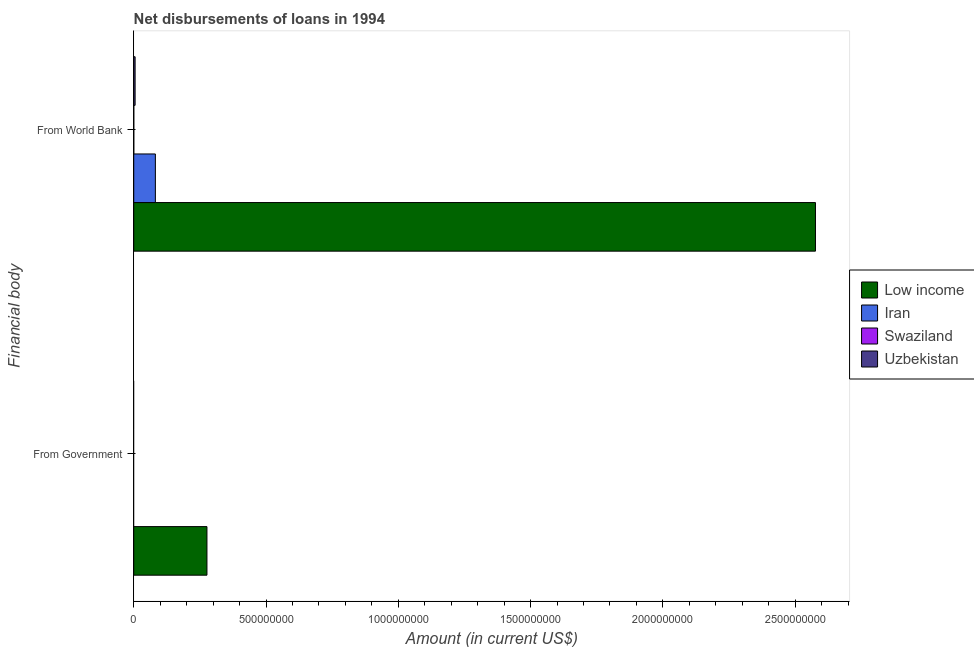How many different coloured bars are there?
Give a very brief answer. 4. What is the label of the 2nd group of bars from the top?
Provide a succinct answer. From Government. What is the net disbursements of loan from world bank in Uzbekistan?
Provide a short and direct response. 5.18e+06. Across all countries, what is the maximum net disbursements of loan from world bank?
Your answer should be very brief. 2.58e+09. Across all countries, what is the minimum net disbursements of loan from government?
Offer a terse response. 0. What is the total net disbursements of loan from government in the graph?
Give a very brief answer. 2.77e+08. What is the difference between the net disbursements of loan from world bank in Low income and that in Uzbekistan?
Make the answer very short. 2.57e+09. What is the difference between the net disbursements of loan from world bank in Low income and the net disbursements of loan from government in Uzbekistan?
Ensure brevity in your answer.  2.58e+09. What is the average net disbursements of loan from government per country?
Your answer should be very brief. 6.92e+07. What is the difference between the net disbursements of loan from government and net disbursements of loan from world bank in Low income?
Your answer should be compact. -2.30e+09. What is the ratio of the net disbursements of loan from world bank in Low income to that in Uzbekistan?
Ensure brevity in your answer.  497.16. Is the net disbursements of loan from world bank in Uzbekistan less than that in Iran?
Ensure brevity in your answer.  Yes. In how many countries, is the net disbursements of loan from world bank greater than the average net disbursements of loan from world bank taken over all countries?
Your response must be concise. 1. How many bars are there?
Ensure brevity in your answer.  5. Are all the bars in the graph horizontal?
Offer a very short reply. Yes. What is the difference between two consecutive major ticks on the X-axis?
Your answer should be very brief. 5.00e+08. Does the graph contain any zero values?
Give a very brief answer. Yes. Does the graph contain grids?
Keep it short and to the point. No. Where does the legend appear in the graph?
Keep it short and to the point. Center right. How many legend labels are there?
Ensure brevity in your answer.  4. What is the title of the graph?
Make the answer very short. Net disbursements of loans in 1994. Does "St. Martin (French part)" appear as one of the legend labels in the graph?
Provide a short and direct response. No. What is the label or title of the Y-axis?
Offer a very short reply. Financial body. What is the Amount (in current US$) in Low income in From Government?
Make the answer very short. 2.77e+08. What is the Amount (in current US$) of Swaziland in From Government?
Offer a very short reply. 0. What is the Amount (in current US$) of Uzbekistan in From Government?
Offer a terse response. 0. What is the Amount (in current US$) of Low income in From World Bank?
Give a very brief answer. 2.58e+09. What is the Amount (in current US$) of Iran in From World Bank?
Your response must be concise. 8.18e+07. What is the Amount (in current US$) in Swaziland in From World Bank?
Ensure brevity in your answer.  1.38e+05. What is the Amount (in current US$) of Uzbekistan in From World Bank?
Ensure brevity in your answer.  5.18e+06. Across all Financial body, what is the maximum Amount (in current US$) in Low income?
Your answer should be very brief. 2.58e+09. Across all Financial body, what is the maximum Amount (in current US$) of Iran?
Make the answer very short. 8.18e+07. Across all Financial body, what is the maximum Amount (in current US$) in Swaziland?
Ensure brevity in your answer.  1.38e+05. Across all Financial body, what is the maximum Amount (in current US$) of Uzbekistan?
Your response must be concise. 5.18e+06. Across all Financial body, what is the minimum Amount (in current US$) in Low income?
Provide a short and direct response. 2.77e+08. Across all Financial body, what is the minimum Amount (in current US$) in Iran?
Provide a short and direct response. 0. What is the total Amount (in current US$) in Low income in the graph?
Give a very brief answer. 2.85e+09. What is the total Amount (in current US$) of Iran in the graph?
Provide a succinct answer. 8.18e+07. What is the total Amount (in current US$) in Swaziland in the graph?
Your answer should be compact. 1.38e+05. What is the total Amount (in current US$) in Uzbekistan in the graph?
Ensure brevity in your answer.  5.18e+06. What is the difference between the Amount (in current US$) in Low income in From Government and that in From World Bank?
Offer a very short reply. -2.30e+09. What is the difference between the Amount (in current US$) in Low income in From Government and the Amount (in current US$) in Iran in From World Bank?
Keep it short and to the point. 1.95e+08. What is the difference between the Amount (in current US$) in Low income in From Government and the Amount (in current US$) in Swaziland in From World Bank?
Keep it short and to the point. 2.77e+08. What is the difference between the Amount (in current US$) in Low income in From Government and the Amount (in current US$) in Uzbekistan in From World Bank?
Keep it short and to the point. 2.72e+08. What is the average Amount (in current US$) in Low income per Financial body?
Give a very brief answer. 1.43e+09. What is the average Amount (in current US$) in Iran per Financial body?
Offer a very short reply. 4.09e+07. What is the average Amount (in current US$) in Swaziland per Financial body?
Your response must be concise. 6.90e+04. What is the average Amount (in current US$) in Uzbekistan per Financial body?
Provide a succinct answer. 2.59e+06. What is the difference between the Amount (in current US$) of Low income and Amount (in current US$) of Iran in From World Bank?
Provide a short and direct response. 2.49e+09. What is the difference between the Amount (in current US$) of Low income and Amount (in current US$) of Swaziland in From World Bank?
Ensure brevity in your answer.  2.58e+09. What is the difference between the Amount (in current US$) in Low income and Amount (in current US$) in Uzbekistan in From World Bank?
Your answer should be compact. 2.57e+09. What is the difference between the Amount (in current US$) in Iran and Amount (in current US$) in Swaziland in From World Bank?
Offer a terse response. 8.17e+07. What is the difference between the Amount (in current US$) of Iran and Amount (in current US$) of Uzbekistan in From World Bank?
Make the answer very short. 7.66e+07. What is the difference between the Amount (in current US$) of Swaziland and Amount (in current US$) of Uzbekistan in From World Bank?
Provide a succinct answer. -5.04e+06. What is the ratio of the Amount (in current US$) of Low income in From Government to that in From World Bank?
Provide a succinct answer. 0.11. What is the difference between the highest and the second highest Amount (in current US$) of Low income?
Your answer should be very brief. 2.30e+09. What is the difference between the highest and the lowest Amount (in current US$) in Low income?
Make the answer very short. 2.30e+09. What is the difference between the highest and the lowest Amount (in current US$) in Iran?
Ensure brevity in your answer.  8.18e+07. What is the difference between the highest and the lowest Amount (in current US$) of Swaziland?
Give a very brief answer. 1.38e+05. What is the difference between the highest and the lowest Amount (in current US$) in Uzbekistan?
Your answer should be compact. 5.18e+06. 